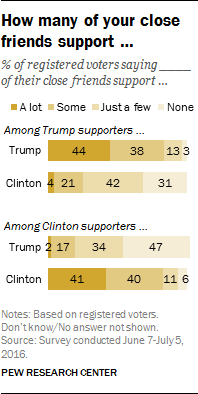Indicate a few pertinent items in this graphic. The sum of the two smallest bars is greater than the third smallest bar. The value of the rightmost upper bar is 3, for the range of numbers starting from 3 and going up to infinity 